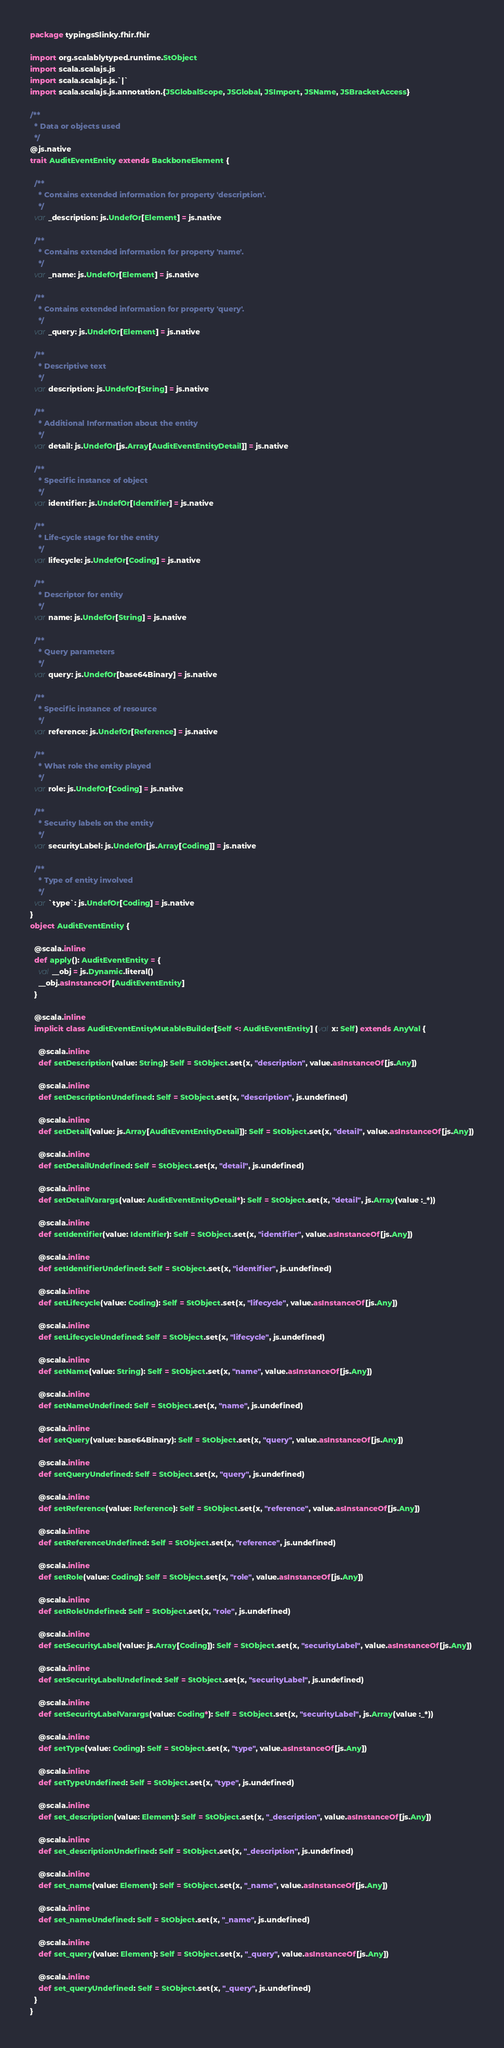Convert code to text. <code><loc_0><loc_0><loc_500><loc_500><_Scala_>package typingsSlinky.fhir.fhir

import org.scalablytyped.runtime.StObject
import scala.scalajs.js
import scala.scalajs.js.`|`
import scala.scalajs.js.annotation.{JSGlobalScope, JSGlobal, JSImport, JSName, JSBracketAccess}

/**
  * Data or objects used
  */
@js.native
trait AuditEventEntity extends BackboneElement {
  
  /**
    * Contains extended information for property 'description'.
    */
  var _description: js.UndefOr[Element] = js.native
  
  /**
    * Contains extended information for property 'name'.
    */
  var _name: js.UndefOr[Element] = js.native
  
  /**
    * Contains extended information for property 'query'.
    */
  var _query: js.UndefOr[Element] = js.native
  
  /**
    * Descriptive text
    */
  var description: js.UndefOr[String] = js.native
  
  /**
    * Additional Information about the entity
    */
  var detail: js.UndefOr[js.Array[AuditEventEntityDetail]] = js.native
  
  /**
    * Specific instance of object
    */
  var identifier: js.UndefOr[Identifier] = js.native
  
  /**
    * Life-cycle stage for the entity
    */
  var lifecycle: js.UndefOr[Coding] = js.native
  
  /**
    * Descriptor for entity
    */
  var name: js.UndefOr[String] = js.native
  
  /**
    * Query parameters
    */
  var query: js.UndefOr[base64Binary] = js.native
  
  /**
    * Specific instance of resource
    */
  var reference: js.UndefOr[Reference] = js.native
  
  /**
    * What role the entity played
    */
  var role: js.UndefOr[Coding] = js.native
  
  /**
    * Security labels on the entity
    */
  var securityLabel: js.UndefOr[js.Array[Coding]] = js.native
  
  /**
    * Type of entity involved
    */
  var `type`: js.UndefOr[Coding] = js.native
}
object AuditEventEntity {
  
  @scala.inline
  def apply(): AuditEventEntity = {
    val __obj = js.Dynamic.literal()
    __obj.asInstanceOf[AuditEventEntity]
  }
  
  @scala.inline
  implicit class AuditEventEntityMutableBuilder[Self <: AuditEventEntity] (val x: Self) extends AnyVal {
    
    @scala.inline
    def setDescription(value: String): Self = StObject.set(x, "description", value.asInstanceOf[js.Any])
    
    @scala.inline
    def setDescriptionUndefined: Self = StObject.set(x, "description", js.undefined)
    
    @scala.inline
    def setDetail(value: js.Array[AuditEventEntityDetail]): Self = StObject.set(x, "detail", value.asInstanceOf[js.Any])
    
    @scala.inline
    def setDetailUndefined: Self = StObject.set(x, "detail", js.undefined)
    
    @scala.inline
    def setDetailVarargs(value: AuditEventEntityDetail*): Self = StObject.set(x, "detail", js.Array(value :_*))
    
    @scala.inline
    def setIdentifier(value: Identifier): Self = StObject.set(x, "identifier", value.asInstanceOf[js.Any])
    
    @scala.inline
    def setIdentifierUndefined: Self = StObject.set(x, "identifier", js.undefined)
    
    @scala.inline
    def setLifecycle(value: Coding): Self = StObject.set(x, "lifecycle", value.asInstanceOf[js.Any])
    
    @scala.inline
    def setLifecycleUndefined: Self = StObject.set(x, "lifecycle", js.undefined)
    
    @scala.inline
    def setName(value: String): Self = StObject.set(x, "name", value.asInstanceOf[js.Any])
    
    @scala.inline
    def setNameUndefined: Self = StObject.set(x, "name", js.undefined)
    
    @scala.inline
    def setQuery(value: base64Binary): Self = StObject.set(x, "query", value.asInstanceOf[js.Any])
    
    @scala.inline
    def setQueryUndefined: Self = StObject.set(x, "query", js.undefined)
    
    @scala.inline
    def setReference(value: Reference): Self = StObject.set(x, "reference", value.asInstanceOf[js.Any])
    
    @scala.inline
    def setReferenceUndefined: Self = StObject.set(x, "reference", js.undefined)
    
    @scala.inline
    def setRole(value: Coding): Self = StObject.set(x, "role", value.asInstanceOf[js.Any])
    
    @scala.inline
    def setRoleUndefined: Self = StObject.set(x, "role", js.undefined)
    
    @scala.inline
    def setSecurityLabel(value: js.Array[Coding]): Self = StObject.set(x, "securityLabel", value.asInstanceOf[js.Any])
    
    @scala.inline
    def setSecurityLabelUndefined: Self = StObject.set(x, "securityLabel", js.undefined)
    
    @scala.inline
    def setSecurityLabelVarargs(value: Coding*): Self = StObject.set(x, "securityLabel", js.Array(value :_*))
    
    @scala.inline
    def setType(value: Coding): Self = StObject.set(x, "type", value.asInstanceOf[js.Any])
    
    @scala.inline
    def setTypeUndefined: Self = StObject.set(x, "type", js.undefined)
    
    @scala.inline
    def set_description(value: Element): Self = StObject.set(x, "_description", value.asInstanceOf[js.Any])
    
    @scala.inline
    def set_descriptionUndefined: Self = StObject.set(x, "_description", js.undefined)
    
    @scala.inline
    def set_name(value: Element): Self = StObject.set(x, "_name", value.asInstanceOf[js.Any])
    
    @scala.inline
    def set_nameUndefined: Self = StObject.set(x, "_name", js.undefined)
    
    @scala.inline
    def set_query(value: Element): Self = StObject.set(x, "_query", value.asInstanceOf[js.Any])
    
    @scala.inline
    def set_queryUndefined: Self = StObject.set(x, "_query", js.undefined)
  }
}
</code> 